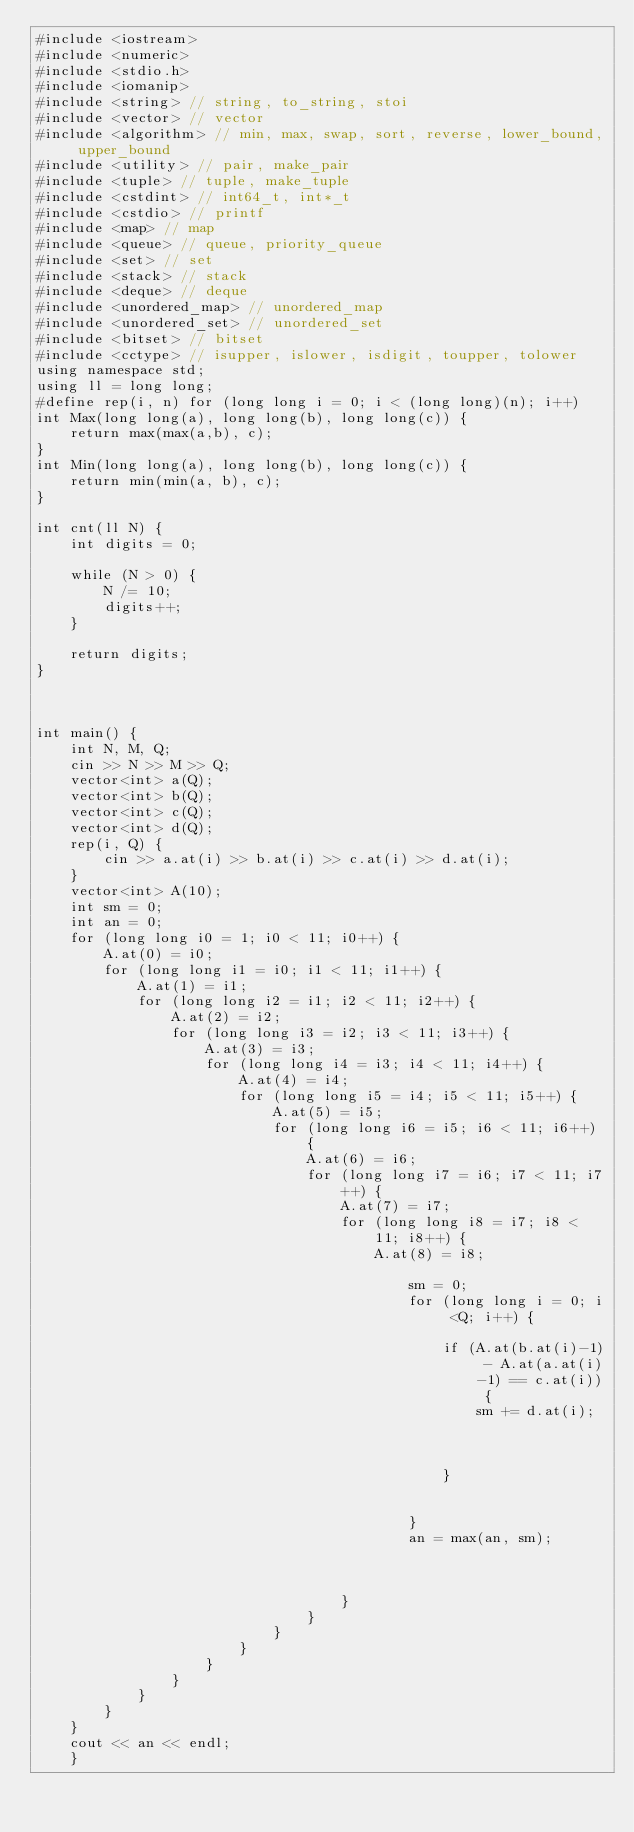Convert code to text. <code><loc_0><loc_0><loc_500><loc_500><_C++_>#include <iostream>
#include <numeric>
#include <stdio.h>
#include <iomanip>
#include <string> // string, to_string, stoi
#include <vector> // vector
#include <algorithm> // min, max, swap, sort, reverse, lower_bound, upper_bound
#include <utility> // pair, make_pair
#include <tuple> // tuple, make_tuple
#include <cstdint> // int64_t, int*_t
#include <cstdio> // printf
#include <map> // map
#include <queue> // queue, priority_queue
#include <set> // set
#include <stack> // stack
#include <deque> // deque
#include <unordered_map> // unordered_map
#include <unordered_set> // unordered_set
#include <bitset> // bitset
#include <cctype> // isupper, islower, isdigit, toupper, tolower
using namespace std;
using ll = long long;
#define rep(i, n) for (long long i = 0; i < (long long)(n); i++)
int Max(long long(a), long long(b), long long(c)) {
	return max(max(a,b), c);
}
int Min(long long(a), long long(b), long long(c)) {
	return min(min(a, b), c);
}

int cnt(ll N) {
	int digits = 0;

	while (N > 0) {
		N /= 10;
		digits++;
	}

	return digits;
}



int main() {
	int N, M, Q;
	cin >> N >> M >> Q;
	vector<int> a(Q);
	vector<int> b(Q);
	vector<int> c(Q);
	vector<int> d(Q);
	rep(i, Q) {
		cin >> a.at(i) >> b.at(i) >> c.at(i) >> d.at(i);
	}
	vector<int> A(10);
	int sm = 0;
	int an = 0;
	for (long long i0 = 1; i0 < 11; i0++) {
		A.at(0) = i0;
		for (long long i1 = i0; i1 < 11; i1++) {
			A.at(1) = i1;
			for (long long i2 = i1; i2 < 11; i2++) {
				A.at(2) = i2;
				for (long long i3 = i2; i3 < 11; i3++) {
					A.at(3) = i3;
					for (long long i4 = i3; i4 < 11; i4++) {
						A.at(4) = i4;
						for (long long i5 = i4; i5 < 11; i5++) {
							A.at(5) = i5;
							for (long long i6 = i5; i6 < 11; i6++) {
								A.at(6) = i6;
								for (long long i7 = i6; i7 < 11; i7++) {
									A.at(7) = i7;
									for (long long i8 = i7; i8 < 11; i8++) {
										A.at(8) = i8;
										
											sm = 0;
											for (long long i = 0; i <Q; i++) {
												
												if (A.at(b.at(i)-1) - A.at(a.at(i)-1) == c.at(i)) {
													sm += d.at(i);
												


												}
												
												
											}
											an = max(an, sm);


										
									}
								}
							}
						}
					}
				}
			}
		}
	}
	cout << an << endl;
	}

	
	
	

	
</code> 